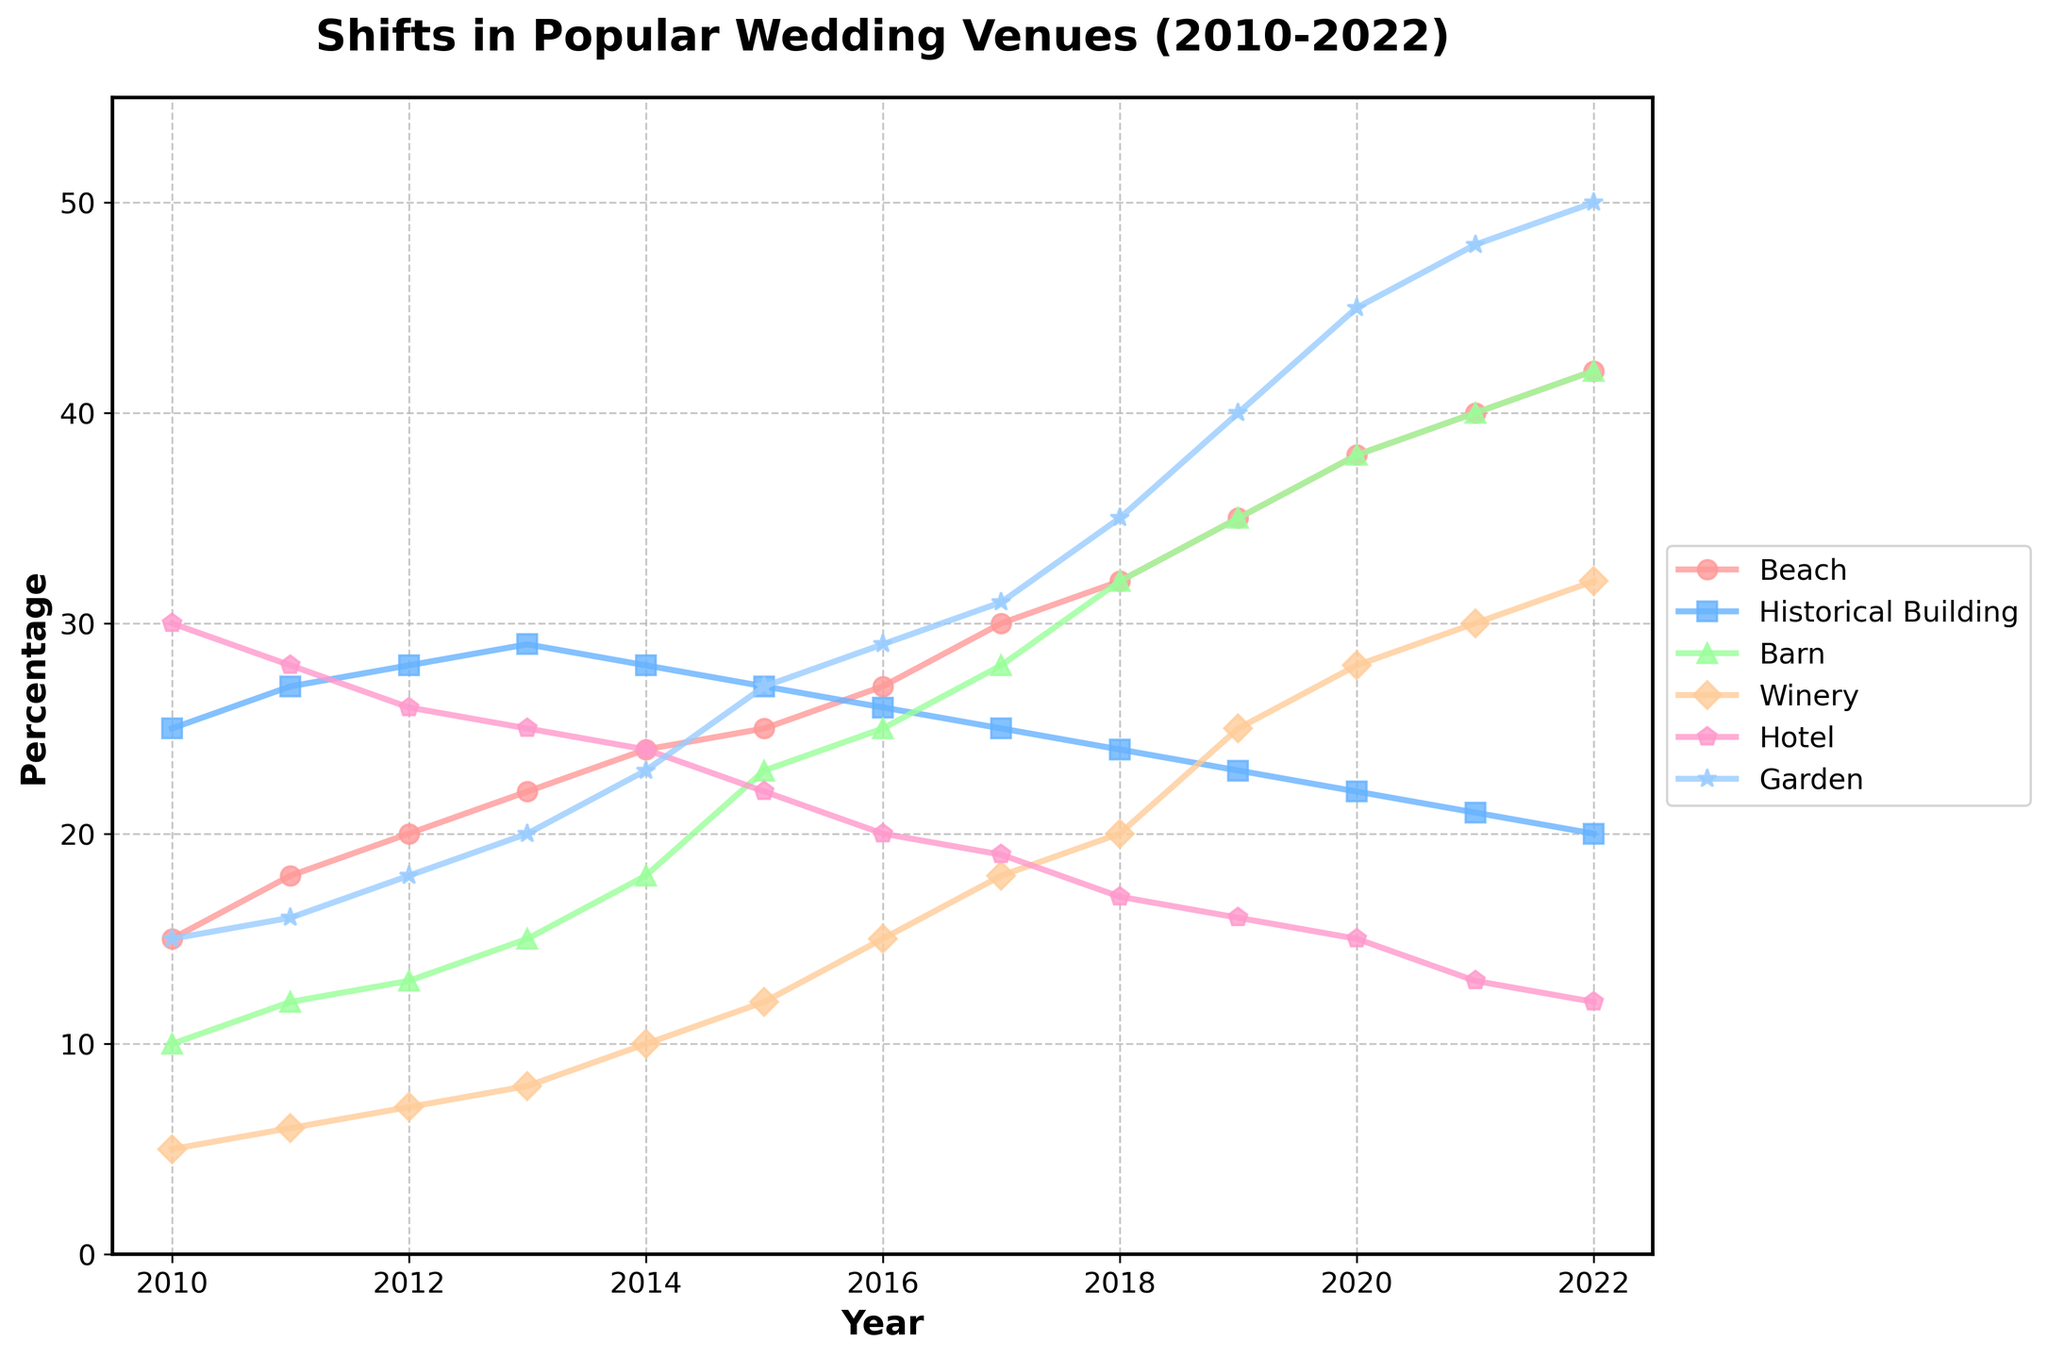What is the general trend for the popularity of beach venues over time? The plot shows a steady increase in the percentage of people choosing beach venues from 2010 to 2022. Starting from 15% in 2010, it gradually rises each year, reaching 42% in 2022.
Answer: Steady increase Which venue type was the most popular in 2010? By looking at the data points for 2010, the venue type with the highest percentage is the Hotel, with 30%.
Answer: Hotel How does the popularity of historical buildings change over the years? The popularity of historical buildings declines gradually over time from a peak of 29% in 2013 to 20% in 2022.
Answer: Gradually declines Between which years did the garden venues see the highest increase in popularity? Analyzing the plot, the garden venues saw the highest increase between 2019 and 2020, jumping from 40% to 45%.
Answer: 2019 and 2020 What is the average percentage of barn venues from 2010 to 2022? Adding the percentages from each year for barn venues (10+12+13+15+18+23+25+28+32+35+38+40+42) and dividing by the number of years (13) gives the average. (10+12+13+15+18+23+25+28+32+35+38+40+42)/13 = 26.54%
Answer: 26.54% Which venue types have shown a clear increase in trend without any decrease over the years? By investigating the trends, both beach and garden venues show a clear increase without any decreases from 2010 to 2022, rising steadily each year.
Answer: Beach and Garden How does the trend in barn venues compare to the trend in winery venues? The plot shows that both barn and winery venues have increasing trends. However, barn venues have a more rapid increase, especially from 2014 onwards, while winery venues show a slower, steadier rise.
Answer: Barn venues increase faster Which year did beach venues surpass historical buildings in popularity? Observing the crossover points on the plot, beach venues surpassed historical buildings in 2014, when beach venues reached 24%, while historical buildings had 28% and began to decline afterwards.
Answer: 2014 By what percentage did hotel venues decrease from 2010 to 2022? Subtracting the percentage in 2022 (12%) from the percentage in 2010 (30%) gives the decrease. 30% - 12% = 18%
Answer: 18% What is the difference in popularity between garden and beach venues in 2020? The percentages for 2020 show garden venues at 45% and beach venues at 38%. The difference is 45% - 38% = 7%.
Answer: 7% 